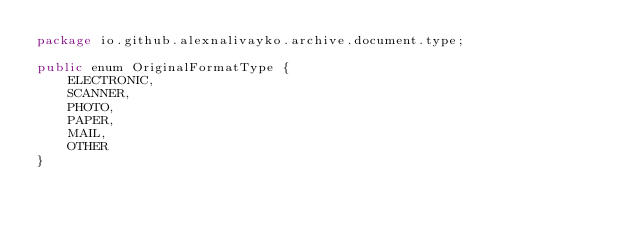<code> <loc_0><loc_0><loc_500><loc_500><_Java_>package io.github.alexnalivayko.archive.document.type;

public enum OriginalFormatType {
	ELECTRONIC,
	SCANNER,
	PHOTO,
	PAPER,
	MAIL,
	OTHER
}</code> 